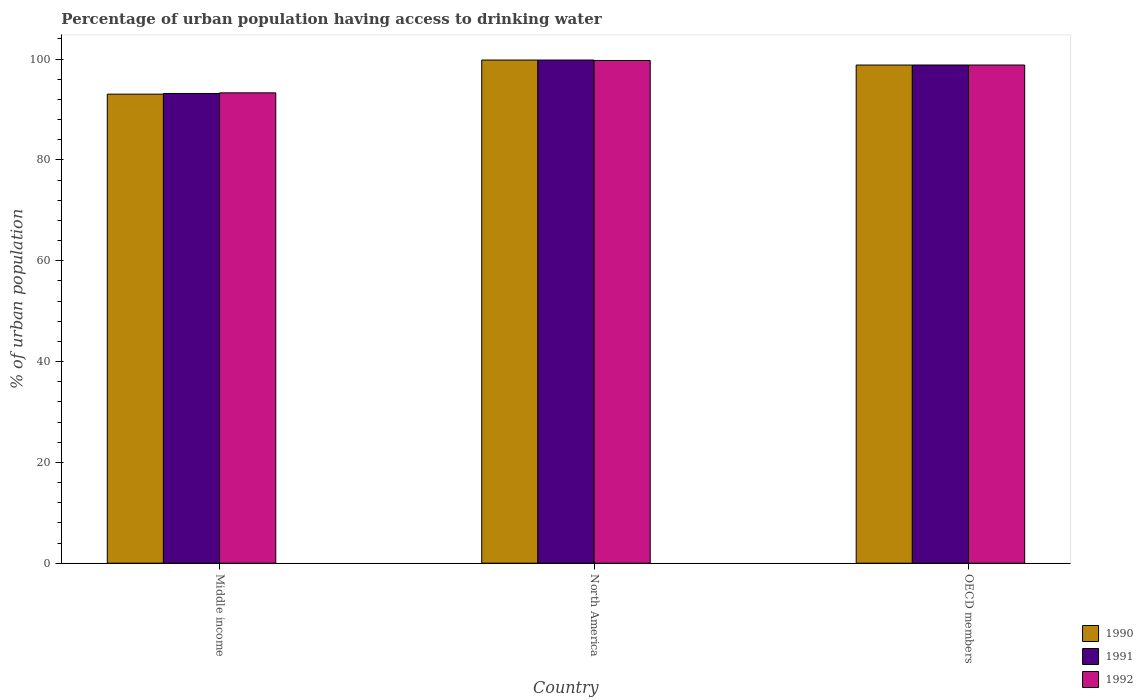How many different coloured bars are there?
Make the answer very short. 3. Are the number of bars per tick equal to the number of legend labels?
Keep it short and to the point. Yes. Are the number of bars on each tick of the X-axis equal?
Your answer should be compact. Yes. What is the label of the 3rd group of bars from the left?
Offer a terse response. OECD members. What is the percentage of urban population having access to drinking water in 1990 in Middle income?
Provide a succinct answer. 93.05. Across all countries, what is the maximum percentage of urban population having access to drinking water in 1990?
Offer a terse response. 99.82. Across all countries, what is the minimum percentage of urban population having access to drinking water in 1991?
Offer a terse response. 93.19. In which country was the percentage of urban population having access to drinking water in 1990 maximum?
Your answer should be compact. North America. In which country was the percentage of urban population having access to drinking water in 1990 minimum?
Provide a succinct answer. Middle income. What is the total percentage of urban population having access to drinking water in 1990 in the graph?
Ensure brevity in your answer.  291.7. What is the difference between the percentage of urban population having access to drinking water in 1990 in Middle income and that in OECD members?
Keep it short and to the point. -5.77. What is the difference between the percentage of urban population having access to drinking water in 1991 in Middle income and the percentage of urban population having access to drinking water in 1990 in OECD members?
Provide a short and direct response. -5.64. What is the average percentage of urban population having access to drinking water in 1992 per country?
Ensure brevity in your answer.  97.29. What is the difference between the percentage of urban population having access to drinking water of/in 1992 and percentage of urban population having access to drinking water of/in 1991 in North America?
Ensure brevity in your answer.  -0.09. In how many countries, is the percentage of urban population having access to drinking water in 1992 greater than 72 %?
Make the answer very short. 3. What is the ratio of the percentage of urban population having access to drinking water in 1991 in Middle income to that in OECD members?
Your answer should be compact. 0.94. Is the percentage of urban population having access to drinking water in 1992 in North America less than that in OECD members?
Give a very brief answer. No. Is the difference between the percentage of urban population having access to drinking water in 1992 in Middle income and OECD members greater than the difference between the percentage of urban population having access to drinking water in 1991 in Middle income and OECD members?
Provide a short and direct response. Yes. What is the difference between the highest and the second highest percentage of urban population having access to drinking water in 1992?
Ensure brevity in your answer.  -0.9. What is the difference between the highest and the lowest percentage of urban population having access to drinking water in 1992?
Provide a succinct answer. 6.42. In how many countries, is the percentage of urban population having access to drinking water in 1990 greater than the average percentage of urban population having access to drinking water in 1990 taken over all countries?
Give a very brief answer. 2. Are all the bars in the graph horizontal?
Provide a succinct answer. No. How many countries are there in the graph?
Provide a succinct answer. 3. Does the graph contain any zero values?
Your answer should be very brief. No. Does the graph contain grids?
Offer a terse response. No. Where does the legend appear in the graph?
Your answer should be compact. Bottom right. What is the title of the graph?
Offer a very short reply. Percentage of urban population having access to drinking water. What is the label or title of the X-axis?
Keep it short and to the point. Country. What is the label or title of the Y-axis?
Give a very brief answer. % of urban population. What is the % of urban population of 1990 in Middle income?
Make the answer very short. 93.05. What is the % of urban population in 1991 in Middle income?
Keep it short and to the point. 93.19. What is the % of urban population in 1992 in Middle income?
Your answer should be very brief. 93.31. What is the % of urban population of 1990 in North America?
Keep it short and to the point. 99.82. What is the % of urban population of 1991 in North America?
Make the answer very short. 99.82. What is the % of urban population in 1992 in North America?
Make the answer very short. 99.73. What is the % of urban population of 1990 in OECD members?
Make the answer very short. 98.83. What is the % of urban population in 1991 in OECD members?
Keep it short and to the point. 98.83. What is the % of urban population of 1992 in OECD members?
Make the answer very short. 98.83. Across all countries, what is the maximum % of urban population in 1990?
Your response must be concise. 99.82. Across all countries, what is the maximum % of urban population in 1991?
Provide a succinct answer. 99.82. Across all countries, what is the maximum % of urban population of 1992?
Make the answer very short. 99.73. Across all countries, what is the minimum % of urban population of 1990?
Provide a succinct answer. 93.05. Across all countries, what is the minimum % of urban population in 1991?
Offer a very short reply. 93.19. Across all countries, what is the minimum % of urban population of 1992?
Make the answer very short. 93.31. What is the total % of urban population in 1990 in the graph?
Give a very brief answer. 291.7. What is the total % of urban population in 1991 in the graph?
Your answer should be compact. 291.84. What is the total % of urban population in 1992 in the graph?
Your answer should be very brief. 291.87. What is the difference between the % of urban population in 1990 in Middle income and that in North America?
Keep it short and to the point. -6.77. What is the difference between the % of urban population in 1991 in Middle income and that in North America?
Offer a terse response. -6.63. What is the difference between the % of urban population of 1992 in Middle income and that in North America?
Offer a very short reply. -6.42. What is the difference between the % of urban population of 1990 in Middle income and that in OECD members?
Ensure brevity in your answer.  -5.77. What is the difference between the % of urban population in 1991 in Middle income and that in OECD members?
Make the answer very short. -5.65. What is the difference between the % of urban population in 1992 in Middle income and that in OECD members?
Provide a short and direct response. -5.52. What is the difference between the % of urban population of 1990 in North America and that in OECD members?
Provide a succinct answer. 0.99. What is the difference between the % of urban population of 1991 in North America and that in OECD members?
Your response must be concise. 0.99. What is the difference between the % of urban population in 1992 in North America and that in OECD members?
Offer a very short reply. 0.9. What is the difference between the % of urban population of 1990 in Middle income and the % of urban population of 1991 in North America?
Make the answer very short. -6.77. What is the difference between the % of urban population in 1990 in Middle income and the % of urban population in 1992 in North America?
Provide a succinct answer. -6.68. What is the difference between the % of urban population of 1991 in Middle income and the % of urban population of 1992 in North America?
Offer a terse response. -6.54. What is the difference between the % of urban population in 1990 in Middle income and the % of urban population in 1991 in OECD members?
Offer a very short reply. -5.78. What is the difference between the % of urban population in 1990 in Middle income and the % of urban population in 1992 in OECD members?
Your answer should be very brief. -5.78. What is the difference between the % of urban population of 1991 in Middle income and the % of urban population of 1992 in OECD members?
Offer a very short reply. -5.64. What is the difference between the % of urban population in 1990 in North America and the % of urban population in 1991 in OECD members?
Offer a terse response. 0.99. What is the average % of urban population in 1990 per country?
Ensure brevity in your answer.  97.23. What is the average % of urban population in 1991 per country?
Give a very brief answer. 97.28. What is the average % of urban population in 1992 per country?
Provide a succinct answer. 97.29. What is the difference between the % of urban population of 1990 and % of urban population of 1991 in Middle income?
Provide a short and direct response. -0.13. What is the difference between the % of urban population in 1990 and % of urban population in 1992 in Middle income?
Ensure brevity in your answer.  -0.26. What is the difference between the % of urban population in 1991 and % of urban population in 1992 in Middle income?
Your response must be concise. -0.12. What is the difference between the % of urban population of 1990 and % of urban population of 1992 in North America?
Provide a succinct answer. 0.09. What is the difference between the % of urban population in 1991 and % of urban population in 1992 in North America?
Offer a very short reply. 0.09. What is the difference between the % of urban population of 1990 and % of urban population of 1991 in OECD members?
Your answer should be very brief. -0.01. What is the difference between the % of urban population in 1990 and % of urban population in 1992 in OECD members?
Offer a terse response. -0. What is the difference between the % of urban population in 1991 and % of urban population in 1992 in OECD members?
Keep it short and to the point. 0. What is the ratio of the % of urban population of 1990 in Middle income to that in North America?
Offer a terse response. 0.93. What is the ratio of the % of urban population of 1991 in Middle income to that in North America?
Your response must be concise. 0.93. What is the ratio of the % of urban population in 1992 in Middle income to that in North America?
Provide a short and direct response. 0.94. What is the ratio of the % of urban population of 1990 in Middle income to that in OECD members?
Make the answer very short. 0.94. What is the ratio of the % of urban population of 1991 in Middle income to that in OECD members?
Your answer should be compact. 0.94. What is the ratio of the % of urban population in 1992 in Middle income to that in OECD members?
Your answer should be compact. 0.94. What is the ratio of the % of urban population in 1991 in North America to that in OECD members?
Give a very brief answer. 1.01. What is the ratio of the % of urban population in 1992 in North America to that in OECD members?
Offer a terse response. 1.01. What is the difference between the highest and the second highest % of urban population of 1990?
Give a very brief answer. 0.99. What is the difference between the highest and the second highest % of urban population in 1991?
Provide a succinct answer. 0.99. What is the difference between the highest and the second highest % of urban population of 1992?
Provide a short and direct response. 0.9. What is the difference between the highest and the lowest % of urban population in 1990?
Provide a short and direct response. 6.77. What is the difference between the highest and the lowest % of urban population in 1991?
Your answer should be compact. 6.63. What is the difference between the highest and the lowest % of urban population in 1992?
Ensure brevity in your answer.  6.42. 